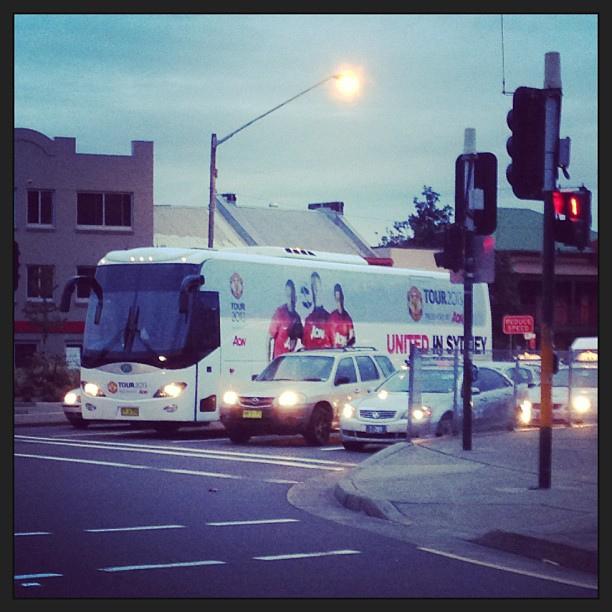Is this a traffic jam?
Give a very brief answer. No. What type of bus is this?
Answer briefly. Tour. What sport is advertised on the bus?
Answer briefly. Soccer. Why are the lights on?
Be succinct. It is getting dark. Where is the cars at?
Answer briefly. Stop light. Has it rained the streets are wet?
Be succinct. No. 